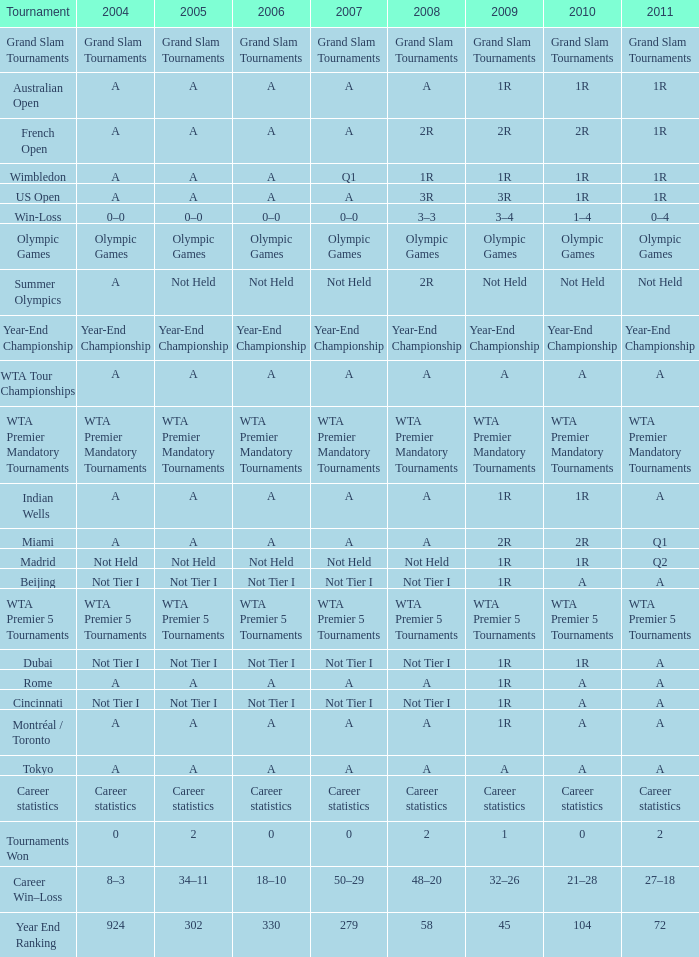What is 2004, if 2005 is "not first tier"? Not Tier I, Not Tier I, Not Tier I. 